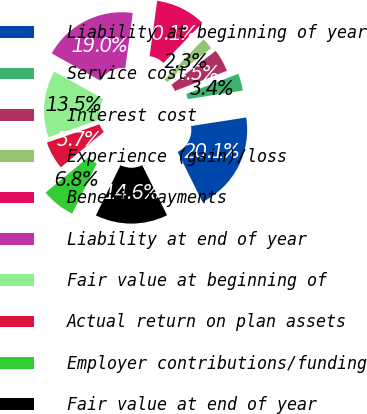Convert chart to OTSL. <chart><loc_0><loc_0><loc_500><loc_500><pie_chart><fcel>Liability at beginning of year<fcel>Service cost<fcel>Interest cost<fcel>Experience (gain)/loss<fcel>Benefit payments<fcel>Liability at end of year<fcel>Fair value at beginning of<fcel>Actual return on plan assets<fcel>Employer contributions/funding<fcel>Fair value at end of year<nl><fcel>20.14%<fcel>3.43%<fcel>4.54%<fcel>2.31%<fcel>10.11%<fcel>19.03%<fcel>13.45%<fcel>5.65%<fcel>6.77%<fcel>14.57%<nl></chart> 